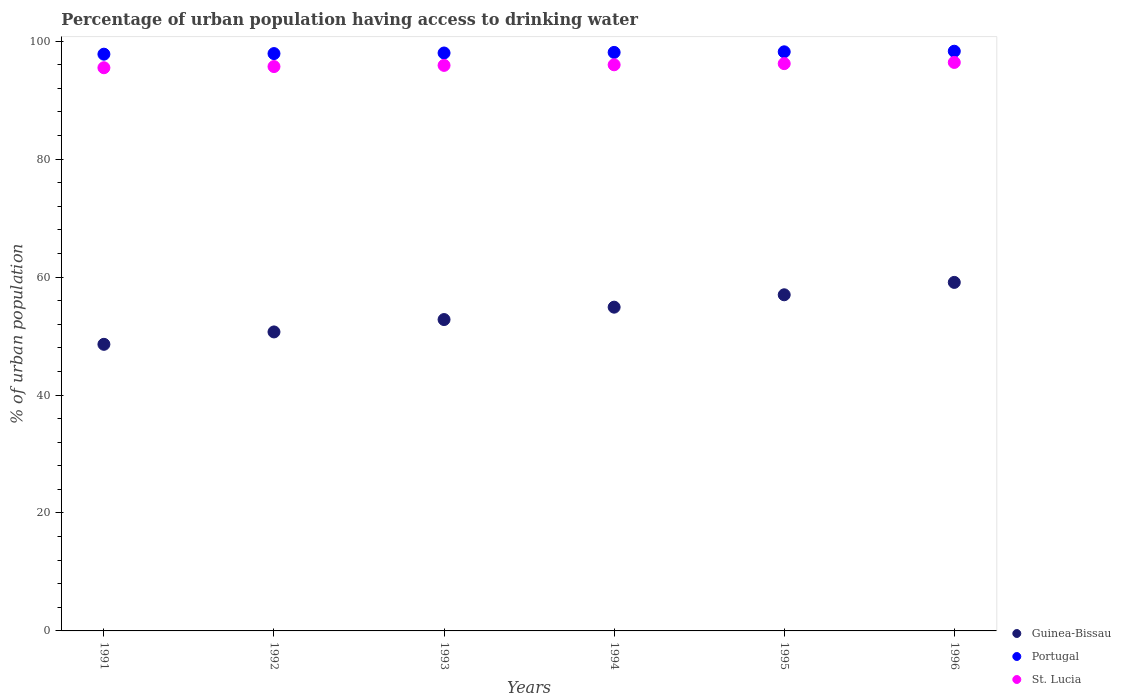Is the number of dotlines equal to the number of legend labels?
Offer a very short reply. Yes. What is the percentage of urban population having access to drinking water in St. Lucia in 1996?
Offer a terse response. 96.4. Across all years, what is the maximum percentage of urban population having access to drinking water in Portugal?
Make the answer very short. 98.3. Across all years, what is the minimum percentage of urban population having access to drinking water in Guinea-Bissau?
Offer a very short reply. 48.6. What is the total percentage of urban population having access to drinking water in Portugal in the graph?
Keep it short and to the point. 588.3. What is the difference between the percentage of urban population having access to drinking water in Guinea-Bissau in 1995 and that in 1996?
Make the answer very short. -2.1. What is the difference between the percentage of urban population having access to drinking water in Guinea-Bissau in 1991 and the percentage of urban population having access to drinking water in St. Lucia in 1994?
Offer a terse response. -47.4. What is the average percentage of urban population having access to drinking water in Guinea-Bissau per year?
Offer a terse response. 53.85. In the year 1992, what is the difference between the percentage of urban population having access to drinking water in Guinea-Bissau and percentage of urban population having access to drinking water in Portugal?
Provide a short and direct response. -47.2. In how many years, is the percentage of urban population having access to drinking water in Portugal greater than 8 %?
Keep it short and to the point. 6. What is the ratio of the percentage of urban population having access to drinking water in Portugal in 1993 to that in 1996?
Offer a terse response. 1. Is the percentage of urban population having access to drinking water in Portugal in 1993 less than that in 1996?
Ensure brevity in your answer.  Yes. What is the difference between the highest and the second highest percentage of urban population having access to drinking water in Portugal?
Provide a short and direct response. 0.1. What is the difference between the highest and the lowest percentage of urban population having access to drinking water in St. Lucia?
Offer a very short reply. 0.9. In how many years, is the percentage of urban population having access to drinking water in Guinea-Bissau greater than the average percentage of urban population having access to drinking water in Guinea-Bissau taken over all years?
Give a very brief answer. 3. Does the percentage of urban population having access to drinking water in Guinea-Bissau monotonically increase over the years?
Your response must be concise. Yes. Is the percentage of urban population having access to drinking water in St. Lucia strictly greater than the percentage of urban population having access to drinking water in Guinea-Bissau over the years?
Provide a short and direct response. Yes. Is the percentage of urban population having access to drinking water in Portugal strictly less than the percentage of urban population having access to drinking water in St. Lucia over the years?
Provide a short and direct response. No. Does the graph contain any zero values?
Your answer should be compact. No. How many legend labels are there?
Provide a short and direct response. 3. How are the legend labels stacked?
Provide a succinct answer. Vertical. What is the title of the graph?
Your answer should be very brief. Percentage of urban population having access to drinking water. What is the label or title of the Y-axis?
Your answer should be very brief. % of urban population. What is the % of urban population of Guinea-Bissau in 1991?
Ensure brevity in your answer.  48.6. What is the % of urban population of Portugal in 1991?
Offer a terse response. 97.8. What is the % of urban population of St. Lucia in 1991?
Your answer should be very brief. 95.5. What is the % of urban population in Guinea-Bissau in 1992?
Give a very brief answer. 50.7. What is the % of urban population in Portugal in 1992?
Your response must be concise. 97.9. What is the % of urban population of St. Lucia in 1992?
Offer a very short reply. 95.7. What is the % of urban population of Guinea-Bissau in 1993?
Offer a very short reply. 52.8. What is the % of urban population of St. Lucia in 1993?
Make the answer very short. 95.9. What is the % of urban population of Guinea-Bissau in 1994?
Provide a short and direct response. 54.9. What is the % of urban population of Portugal in 1994?
Your answer should be very brief. 98.1. What is the % of urban population in St. Lucia in 1994?
Give a very brief answer. 96. What is the % of urban population of Guinea-Bissau in 1995?
Provide a succinct answer. 57. What is the % of urban population in Portugal in 1995?
Your response must be concise. 98.2. What is the % of urban population in St. Lucia in 1995?
Your answer should be compact. 96.2. What is the % of urban population of Guinea-Bissau in 1996?
Make the answer very short. 59.1. What is the % of urban population in Portugal in 1996?
Offer a very short reply. 98.3. What is the % of urban population in St. Lucia in 1996?
Ensure brevity in your answer.  96.4. Across all years, what is the maximum % of urban population in Guinea-Bissau?
Your answer should be compact. 59.1. Across all years, what is the maximum % of urban population of Portugal?
Your answer should be compact. 98.3. Across all years, what is the maximum % of urban population of St. Lucia?
Make the answer very short. 96.4. Across all years, what is the minimum % of urban population in Guinea-Bissau?
Offer a terse response. 48.6. Across all years, what is the minimum % of urban population in Portugal?
Offer a very short reply. 97.8. Across all years, what is the minimum % of urban population of St. Lucia?
Your answer should be compact. 95.5. What is the total % of urban population of Guinea-Bissau in the graph?
Make the answer very short. 323.1. What is the total % of urban population of Portugal in the graph?
Offer a very short reply. 588.3. What is the total % of urban population of St. Lucia in the graph?
Ensure brevity in your answer.  575.7. What is the difference between the % of urban population of Portugal in 1991 and that in 1992?
Your response must be concise. -0.1. What is the difference between the % of urban population in St. Lucia in 1991 and that in 1993?
Your response must be concise. -0.4. What is the difference between the % of urban population of St. Lucia in 1991 and that in 1995?
Your response must be concise. -0.7. What is the difference between the % of urban population in Guinea-Bissau in 1992 and that in 1993?
Make the answer very short. -2.1. What is the difference between the % of urban population of St. Lucia in 1992 and that in 1993?
Offer a terse response. -0.2. What is the difference between the % of urban population of St. Lucia in 1992 and that in 1994?
Give a very brief answer. -0.3. What is the difference between the % of urban population in Guinea-Bissau in 1992 and that in 1995?
Give a very brief answer. -6.3. What is the difference between the % of urban population of St. Lucia in 1992 and that in 1995?
Make the answer very short. -0.5. What is the difference between the % of urban population in St. Lucia in 1992 and that in 1996?
Ensure brevity in your answer.  -0.7. What is the difference between the % of urban population in Guinea-Bissau in 1993 and that in 1994?
Keep it short and to the point. -2.1. What is the difference between the % of urban population of St. Lucia in 1993 and that in 1994?
Offer a terse response. -0.1. What is the difference between the % of urban population of Guinea-Bissau in 1993 and that in 1995?
Your answer should be very brief. -4.2. What is the difference between the % of urban population of Guinea-Bissau in 1993 and that in 1996?
Provide a succinct answer. -6.3. What is the difference between the % of urban population of St. Lucia in 1993 and that in 1996?
Make the answer very short. -0.5. What is the difference between the % of urban population in St. Lucia in 1994 and that in 1995?
Ensure brevity in your answer.  -0.2. What is the difference between the % of urban population in Portugal in 1994 and that in 1996?
Give a very brief answer. -0.2. What is the difference between the % of urban population of Guinea-Bissau in 1995 and that in 1996?
Your answer should be compact. -2.1. What is the difference between the % of urban population of Guinea-Bissau in 1991 and the % of urban population of Portugal in 1992?
Offer a very short reply. -49.3. What is the difference between the % of urban population of Guinea-Bissau in 1991 and the % of urban population of St. Lucia in 1992?
Give a very brief answer. -47.1. What is the difference between the % of urban population of Guinea-Bissau in 1991 and the % of urban population of Portugal in 1993?
Your response must be concise. -49.4. What is the difference between the % of urban population of Guinea-Bissau in 1991 and the % of urban population of St. Lucia in 1993?
Give a very brief answer. -47.3. What is the difference between the % of urban population of Portugal in 1991 and the % of urban population of St. Lucia in 1993?
Make the answer very short. 1.9. What is the difference between the % of urban population in Guinea-Bissau in 1991 and the % of urban population in Portugal in 1994?
Provide a short and direct response. -49.5. What is the difference between the % of urban population in Guinea-Bissau in 1991 and the % of urban population in St. Lucia in 1994?
Your answer should be very brief. -47.4. What is the difference between the % of urban population of Guinea-Bissau in 1991 and the % of urban population of Portugal in 1995?
Give a very brief answer. -49.6. What is the difference between the % of urban population in Guinea-Bissau in 1991 and the % of urban population in St. Lucia in 1995?
Offer a very short reply. -47.6. What is the difference between the % of urban population of Portugal in 1991 and the % of urban population of St. Lucia in 1995?
Offer a very short reply. 1.6. What is the difference between the % of urban population of Guinea-Bissau in 1991 and the % of urban population of Portugal in 1996?
Make the answer very short. -49.7. What is the difference between the % of urban population in Guinea-Bissau in 1991 and the % of urban population in St. Lucia in 1996?
Ensure brevity in your answer.  -47.8. What is the difference between the % of urban population of Portugal in 1991 and the % of urban population of St. Lucia in 1996?
Ensure brevity in your answer.  1.4. What is the difference between the % of urban population in Guinea-Bissau in 1992 and the % of urban population in Portugal in 1993?
Ensure brevity in your answer.  -47.3. What is the difference between the % of urban population of Guinea-Bissau in 1992 and the % of urban population of St. Lucia in 1993?
Offer a very short reply. -45.2. What is the difference between the % of urban population in Guinea-Bissau in 1992 and the % of urban population in Portugal in 1994?
Your answer should be compact. -47.4. What is the difference between the % of urban population in Guinea-Bissau in 1992 and the % of urban population in St. Lucia in 1994?
Offer a very short reply. -45.3. What is the difference between the % of urban population of Guinea-Bissau in 1992 and the % of urban population of Portugal in 1995?
Make the answer very short. -47.5. What is the difference between the % of urban population of Guinea-Bissau in 1992 and the % of urban population of St. Lucia in 1995?
Give a very brief answer. -45.5. What is the difference between the % of urban population in Guinea-Bissau in 1992 and the % of urban population in Portugal in 1996?
Provide a succinct answer. -47.6. What is the difference between the % of urban population of Guinea-Bissau in 1992 and the % of urban population of St. Lucia in 1996?
Give a very brief answer. -45.7. What is the difference between the % of urban population in Guinea-Bissau in 1993 and the % of urban population in Portugal in 1994?
Ensure brevity in your answer.  -45.3. What is the difference between the % of urban population of Guinea-Bissau in 1993 and the % of urban population of St. Lucia in 1994?
Provide a short and direct response. -43.2. What is the difference between the % of urban population of Portugal in 1993 and the % of urban population of St. Lucia in 1994?
Provide a short and direct response. 2. What is the difference between the % of urban population of Guinea-Bissau in 1993 and the % of urban population of Portugal in 1995?
Make the answer very short. -45.4. What is the difference between the % of urban population of Guinea-Bissau in 1993 and the % of urban population of St. Lucia in 1995?
Offer a terse response. -43.4. What is the difference between the % of urban population of Guinea-Bissau in 1993 and the % of urban population of Portugal in 1996?
Your answer should be compact. -45.5. What is the difference between the % of urban population in Guinea-Bissau in 1993 and the % of urban population in St. Lucia in 1996?
Your response must be concise. -43.6. What is the difference between the % of urban population of Guinea-Bissau in 1994 and the % of urban population of Portugal in 1995?
Keep it short and to the point. -43.3. What is the difference between the % of urban population of Guinea-Bissau in 1994 and the % of urban population of St. Lucia in 1995?
Offer a very short reply. -41.3. What is the difference between the % of urban population in Guinea-Bissau in 1994 and the % of urban population in Portugal in 1996?
Make the answer very short. -43.4. What is the difference between the % of urban population of Guinea-Bissau in 1994 and the % of urban population of St. Lucia in 1996?
Offer a very short reply. -41.5. What is the difference between the % of urban population in Portugal in 1994 and the % of urban population in St. Lucia in 1996?
Offer a very short reply. 1.7. What is the difference between the % of urban population in Guinea-Bissau in 1995 and the % of urban population in Portugal in 1996?
Your response must be concise. -41.3. What is the difference between the % of urban population of Guinea-Bissau in 1995 and the % of urban population of St. Lucia in 1996?
Offer a very short reply. -39.4. What is the average % of urban population in Guinea-Bissau per year?
Your response must be concise. 53.85. What is the average % of urban population of Portugal per year?
Offer a terse response. 98.05. What is the average % of urban population in St. Lucia per year?
Offer a very short reply. 95.95. In the year 1991, what is the difference between the % of urban population in Guinea-Bissau and % of urban population in Portugal?
Offer a terse response. -49.2. In the year 1991, what is the difference between the % of urban population in Guinea-Bissau and % of urban population in St. Lucia?
Offer a very short reply. -46.9. In the year 1991, what is the difference between the % of urban population of Portugal and % of urban population of St. Lucia?
Offer a very short reply. 2.3. In the year 1992, what is the difference between the % of urban population of Guinea-Bissau and % of urban population of Portugal?
Provide a succinct answer. -47.2. In the year 1992, what is the difference between the % of urban population of Guinea-Bissau and % of urban population of St. Lucia?
Ensure brevity in your answer.  -45. In the year 1992, what is the difference between the % of urban population of Portugal and % of urban population of St. Lucia?
Keep it short and to the point. 2.2. In the year 1993, what is the difference between the % of urban population in Guinea-Bissau and % of urban population in Portugal?
Provide a succinct answer. -45.2. In the year 1993, what is the difference between the % of urban population of Guinea-Bissau and % of urban population of St. Lucia?
Provide a short and direct response. -43.1. In the year 1993, what is the difference between the % of urban population of Portugal and % of urban population of St. Lucia?
Offer a very short reply. 2.1. In the year 1994, what is the difference between the % of urban population in Guinea-Bissau and % of urban population in Portugal?
Offer a terse response. -43.2. In the year 1994, what is the difference between the % of urban population in Guinea-Bissau and % of urban population in St. Lucia?
Provide a short and direct response. -41.1. In the year 1995, what is the difference between the % of urban population in Guinea-Bissau and % of urban population in Portugal?
Make the answer very short. -41.2. In the year 1995, what is the difference between the % of urban population in Guinea-Bissau and % of urban population in St. Lucia?
Your response must be concise. -39.2. In the year 1996, what is the difference between the % of urban population of Guinea-Bissau and % of urban population of Portugal?
Make the answer very short. -39.2. In the year 1996, what is the difference between the % of urban population in Guinea-Bissau and % of urban population in St. Lucia?
Provide a short and direct response. -37.3. What is the ratio of the % of urban population in Guinea-Bissau in 1991 to that in 1992?
Offer a very short reply. 0.96. What is the ratio of the % of urban population in Portugal in 1991 to that in 1992?
Ensure brevity in your answer.  1. What is the ratio of the % of urban population in St. Lucia in 1991 to that in 1992?
Your answer should be compact. 1. What is the ratio of the % of urban population in Guinea-Bissau in 1991 to that in 1993?
Offer a very short reply. 0.92. What is the ratio of the % of urban population in St. Lucia in 1991 to that in 1993?
Provide a succinct answer. 1. What is the ratio of the % of urban population of Guinea-Bissau in 1991 to that in 1994?
Provide a succinct answer. 0.89. What is the ratio of the % of urban population in St. Lucia in 1991 to that in 1994?
Offer a terse response. 0.99. What is the ratio of the % of urban population in Guinea-Bissau in 1991 to that in 1995?
Offer a terse response. 0.85. What is the ratio of the % of urban population of Portugal in 1991 to that in 1995?
Your response must be concise. 1. What is the ratio of the % of urban population of St. Lucia in 1991 to that in 1995?
Make the answer very short. 0.99. What is the ratio of the % of urban population of Guinea-Bissau in 1991 to that in 1996?
Provide a short and direct response. 0.82. What is the ratio of the % of urban population in Guinea-Bissau in 1992 to that in 1993?
Your answer should be very brief. 0.96. What is the ratio of the % of urban population of Portugal in 1992 to that in 1993?
Offer a terse response. 1. What is the ratio of the % of urban population in Guinea-Bissau in 1992 to that in 1994?
Keep it short and to the point. 0.92. What is the ratio of the % of urban population in Guinea-Bissau in 1992 to that in 1995?
Offer a terse response. 0.89. What is the ratio of the % of urban population in Portugal in 1992 to that in 1995?
Your response must be concise. 1. What is the ratio of the % of urban population of St. Lucia in 1992 to that in 1995?
Provide a short and direct response. 0.99. What is the ratio of the % of urban population in Guinea-Bissau in 1992 to that in 1996?
Provide a short and direct response. 0.86. What is the ratio of the % of urban population of Guinea-Bissau in 1993 to that in 1994?
Offer a very short reply. 0.96. What is the ratio of the % of urban population in Portugal in 1993 to that in 1994?
Your response must be concise. 1. What is the ratio of the % of urban population of St. Lucia in 1993 to that in 1994?
Give a very brief answer. 1. What is the ratio of the % of urban population in Guinea-Bissau in 1993 to that in 1995?
Offer a very short reply. 0.93. What is the ratio of the % of urban population of St. Lucia in 1993 to that in 1995?
Provide a succinct answer. 1. What is the ratio of the % of urban population in Guinea-Bissau in 1993 to that in 1996?
Ensure brevity in your answer.  0.89. What is the ratio of the % of urban population in Portugal in 1993 to that in 1996?
Offer a very short reply. 1. What is the ratio of the % of urban population in Guinea-Bissau in 1994 to that in 1995?
Your answer should be very brief. 0.96. What is the ratio of the % of urban population of Portugal in 1994 to that in 1995?
Offer a very short reply. 1. What is the ratio of the % of urban population in Guinea-Bissau in 1994 to that in 1996?
Ensure brevity in your answer.  0.93. What is the ratio of the % of urban population of Portugal in 1994 to that in 1996?
Offer a terse response. 1. What is the ratio of the % of urban population in St. Lucia in 1994 to that in 1996?
Provide a succinct answer. 1. What is the ratio of the % of urban population in Guinea-Bissau in 1995 to that in 1996?
Ensure brevity in your answer.  0.96. What is the ratio of the % of urban population in Portugal in 1995 to that in 1996?
Offer a terse response. 1. What is the ratio of the % of urban population in St. Lucia in 1995 to that in 1996?
Provide a short and direct response. 1. What is the difference between the highest and the second highest % of urban population of Portugal?
Keep it short and to the point. 0.1. What is the difference between the highest and the lowest % of urban population in St. Lucia?
Keep it short and to the point. 0.9. 